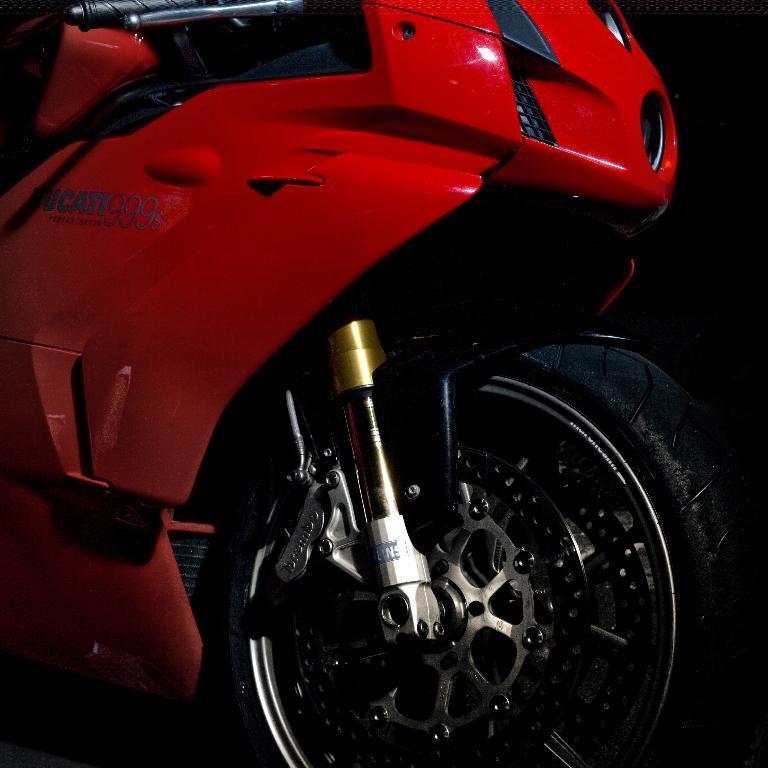Can you describe this image briefly? In this image we can see a red color bike which is truncated. 